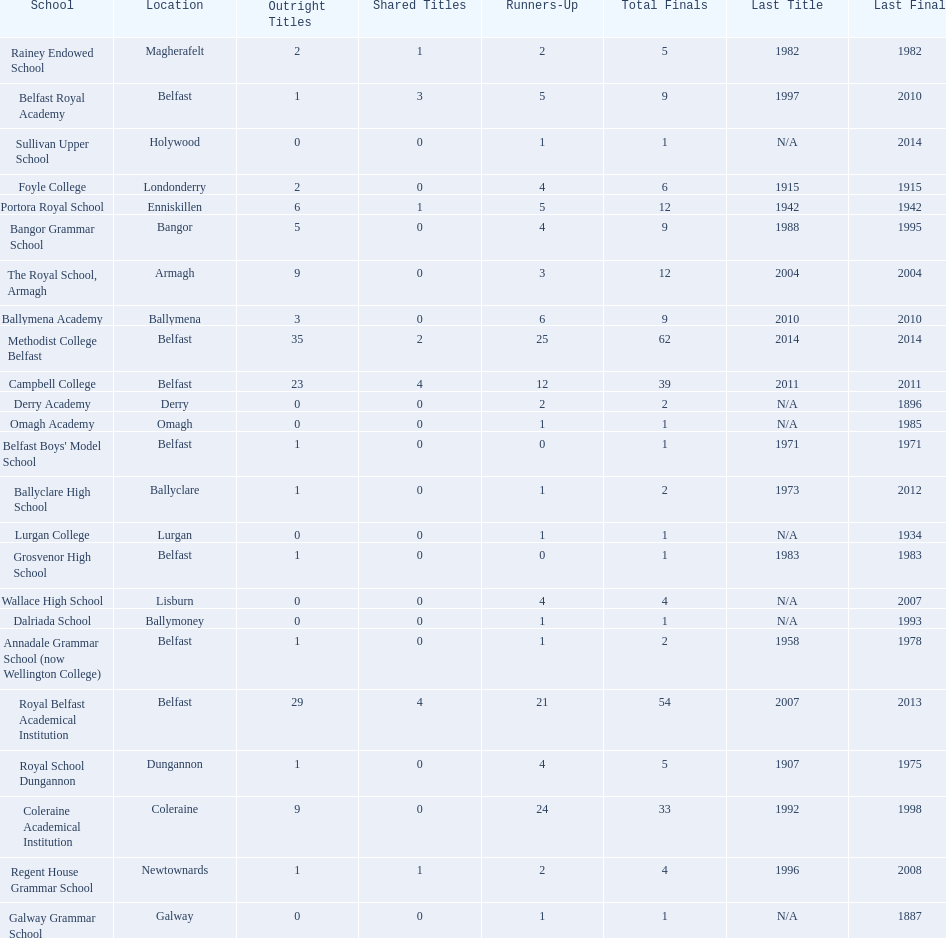How many schools are there? Methodist College Belfast, Royal Belfast Academical Institution, Campbell College, Coleraine Academical Institution, The Royal School, Armagh, Portora Royal School, Bangor Grammar School, Ballymena Academy, Rainey Endowed School, Foyle College, Belfast Royal Academy, Regent House Grammar School, Royal School Dungannon, Annadale Grammar School (now Wellington College), Ballyclare High School, Belfast Boys' Model School, Grosvenor High School, Wallace High School, Derry Academy, Dalriada School, Galway Grammar School, Lurgan College, Omagh Academy, Sullivan Upper School. How many outright titles does the coleraine academical institution have? 9. What other school has the same number of outright titles? The Royal School, Armagh. 